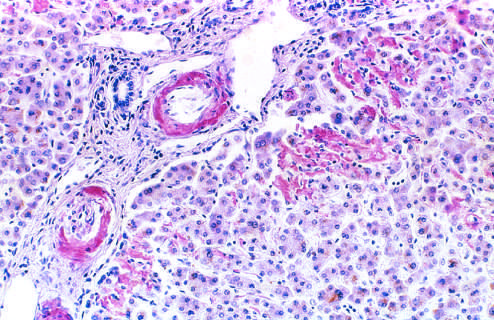does graft damage reveal pink-red deposits of amyloid in the walls of blood vessels and along sinusoids?
Answer the question using a single word or phrase. No 